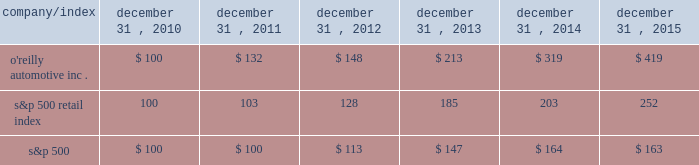Stock performance graph : the graph below shows the cumulative total shareholder return assuming the investment of $ 100 , on december 31 , 2010 , and the reinvestment of dividends thereafter , if any , in the company's common stock versus the standard and poor's s&p 500 retail index ( "s&p 500 retail index" ) and the standard and poor's s&p 500 index ( "s&p 500" ) . .

What is the roi of an investment in the o'reilly automotive inc . from 2010 to 2011? 
Computations: ((132 - 100) / 100)
Answer: 0.32. 